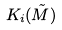<formula> <loc_0><loc_0><loc_500><loc_500>K _ { i } ( \tilde { M } )</formula> 